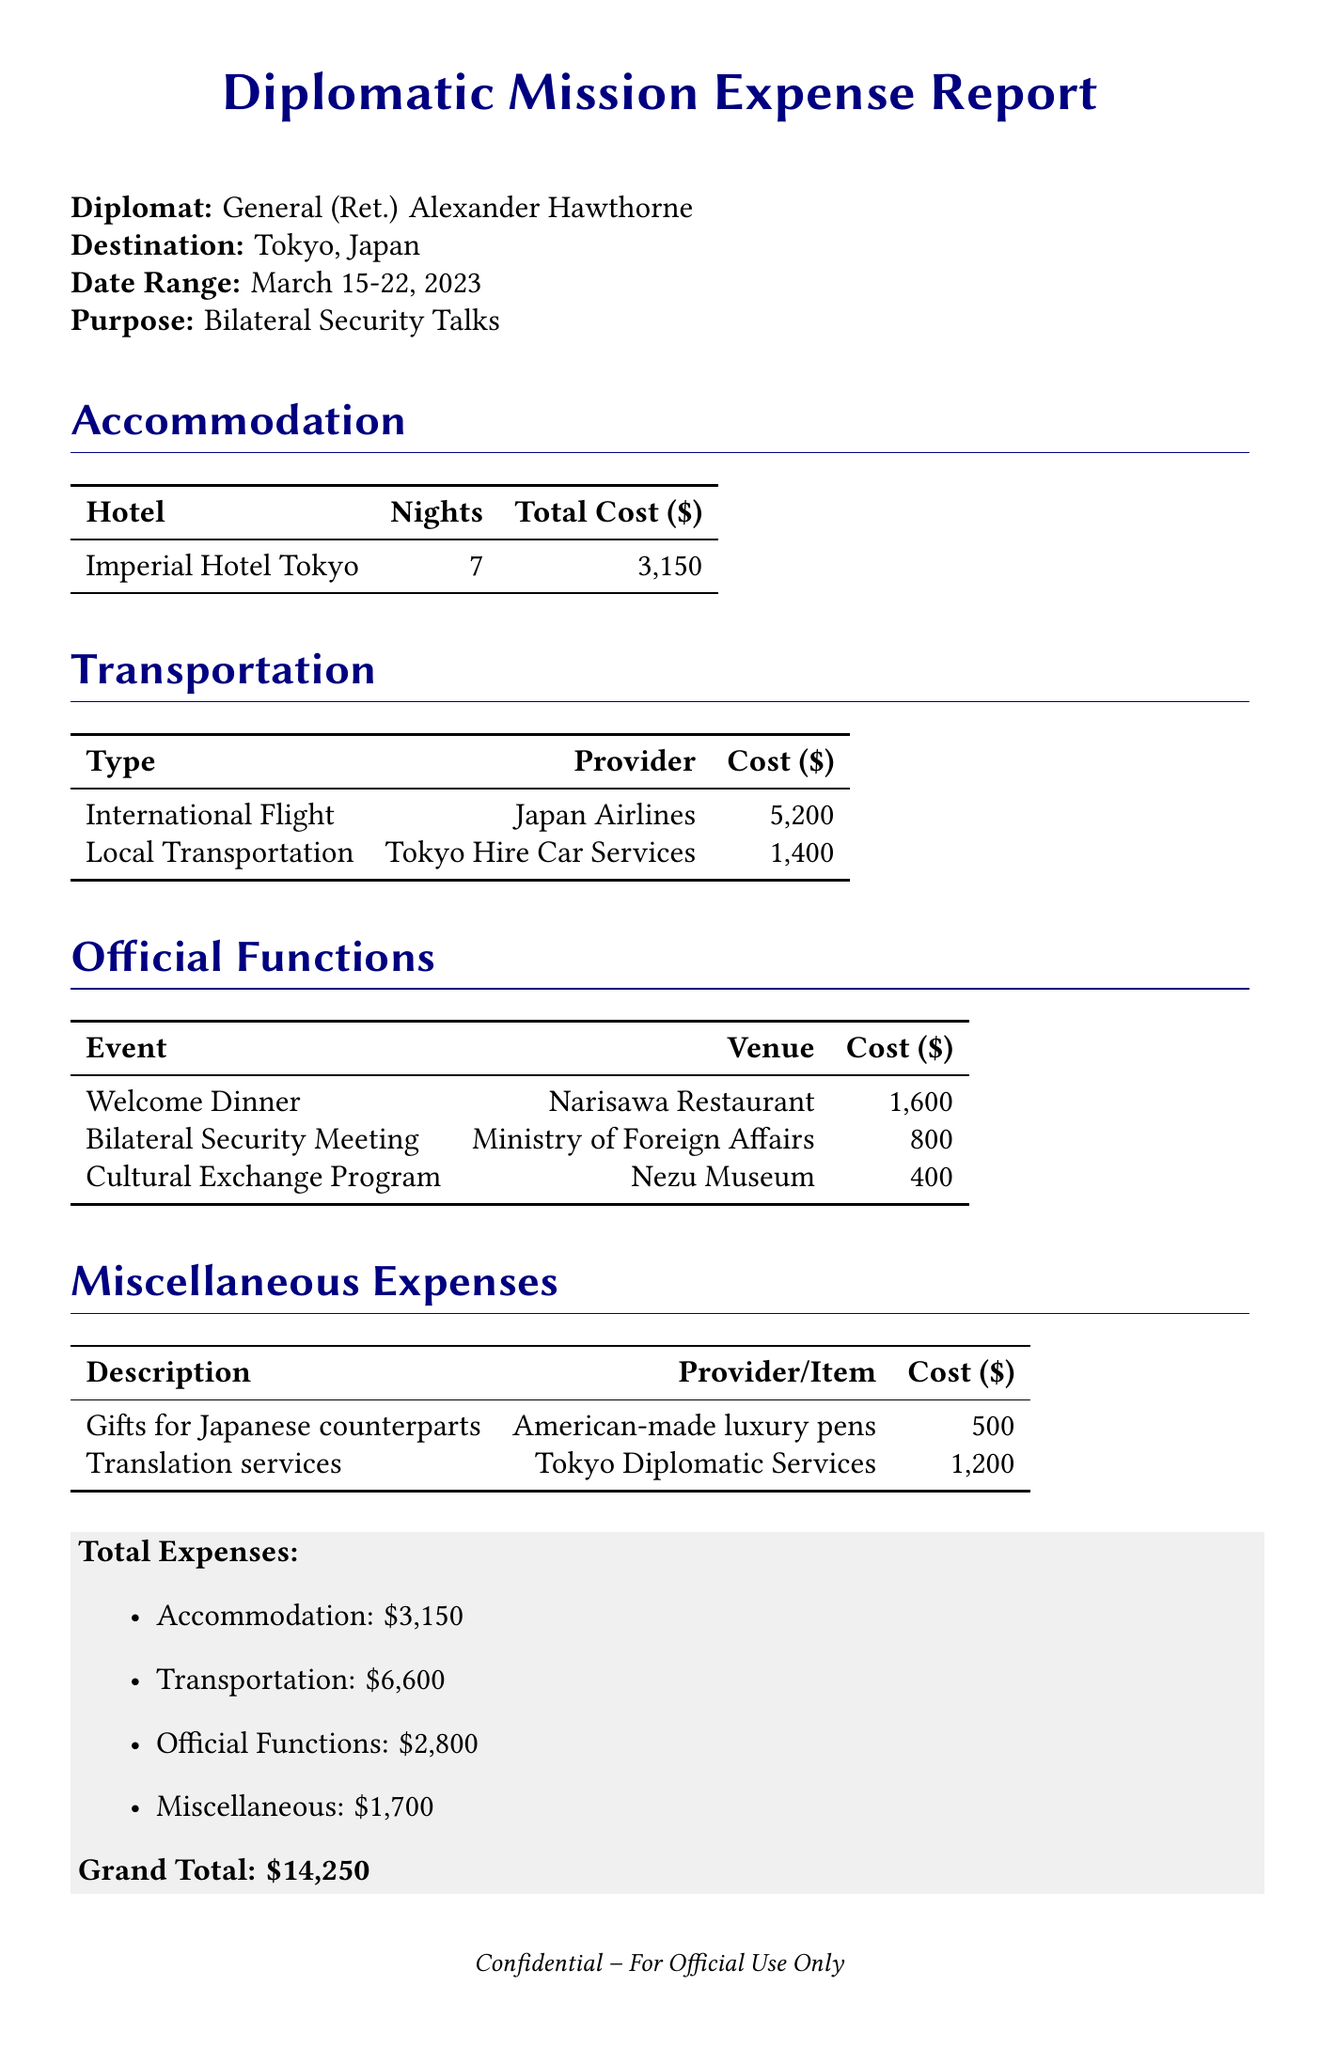What is the diplomat's name? The document provides the name of the diplomat as General (Ret.) Alexander Hawthorne.
Answer: General (Ret.) Alexander Hawthorne What is the destination of the trip? The destination specified in the document is Tokyo, Japan.
Answer: Tokyo, Japan How many nights did the diplomat stay? The number of nights spent in accommodation is listed as 7.
Answer: 7 What was the total cost for local transportation? The total cost for local transportation is indicated as 1,400.
Answer: 1,400 What was the cost of the welcome dinner? The cost for the welcome dinner at Narisawa Restaurant is shown to be 1,600.
Answer: 1,600 What is the total expense for accommodation? The total expense for accommodation is explicitly listed as 3,150.
Answer: 3,150 How much was spent on gifts for Japanese counterparts? The document states the cost for gifts for Japanese counterparts is 500.
Answer: 500 What is the grand total of all expenses? The grand total of all expenses at the end of the document is 14,250.
Answer: 14,250 How many attendees were at the bilateral security meeting? The document mentions that there were 8 attendees at the welcome dinner.
Answer: 8 Which airline was used for the international flight? The document identifies Japan Airlines as the airline for the international flight.
Answer: Japan Airlines 